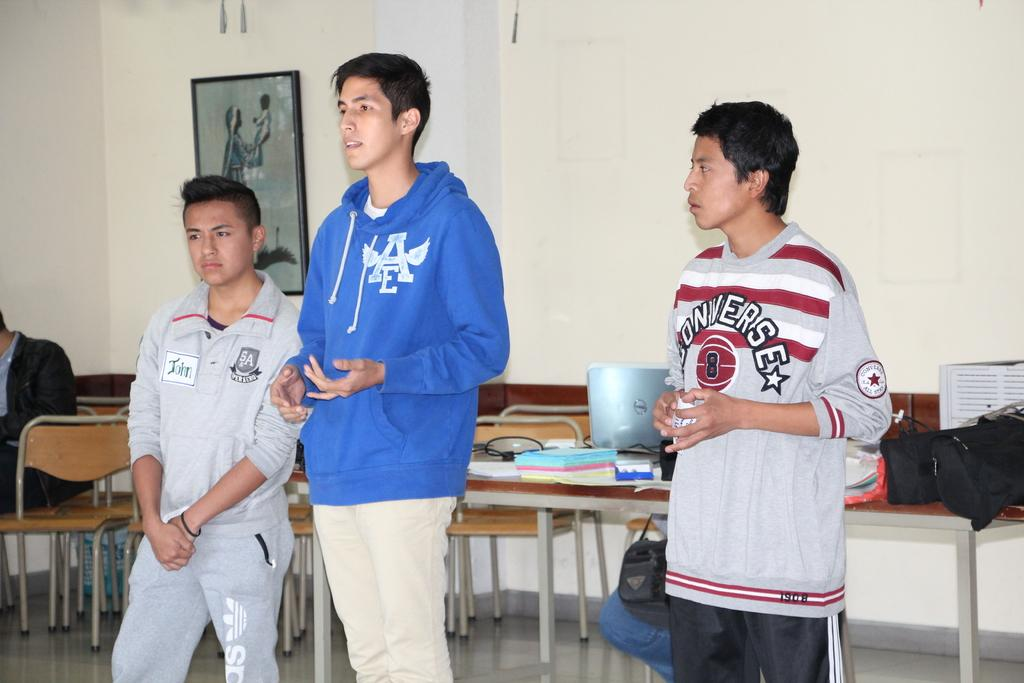<image>
Summarize the visual content of the image. A boy in an AE hoodie stands between another boy in a converse shirt and boy in an SA shirt. 